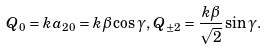<formula> <loc_0><loc_0><loc_500><loc_500>Q _ { 0 } = k a _ { 2 0 } = k \beta \cos \gamma , \, Q _ { \pm 2 } = \frac { k \beta } { \sqrt { 2 } } \sin \gamma .</formula> 